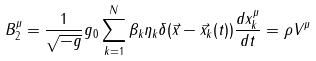<formula> <loc_0><loc_0><loc_500><loc_500>B ^ { \mu } _ { 2 } = \frac { 1 } { \sqrt { - g } } g _ { 0 } \sum ^ { N } _ { k = 1 } \beta _ { k } \eta _ { k } \delta ( \vec { x } - \vec { x } _ { k } ( t ) ) \frac { d x ^ { \mu } _ { k } } { d t } = \rho { V } ^ { \mu }</formula> 